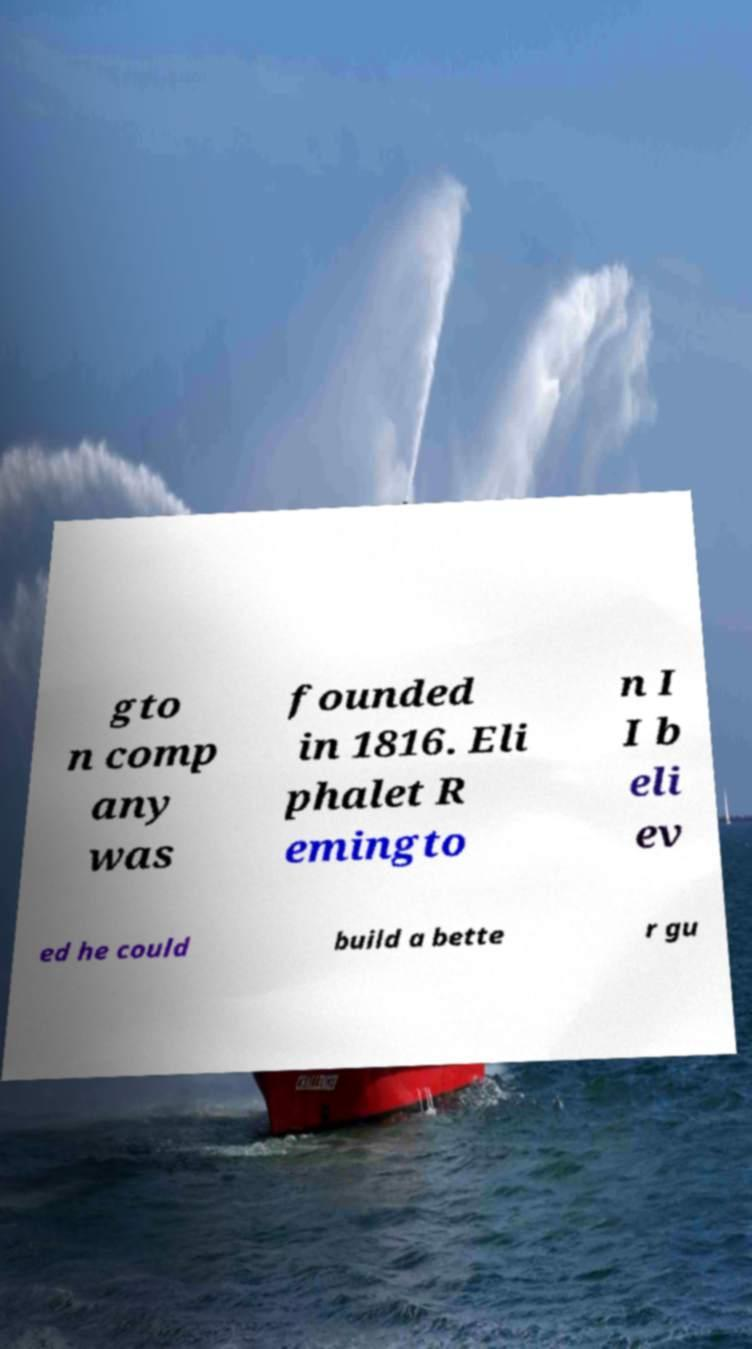Please read and relay the text visible in this image. What does it say? gto n comp any was founded in 1816. Eli phalet R emingto n I I b eli ev ed he could build a bette r gu 